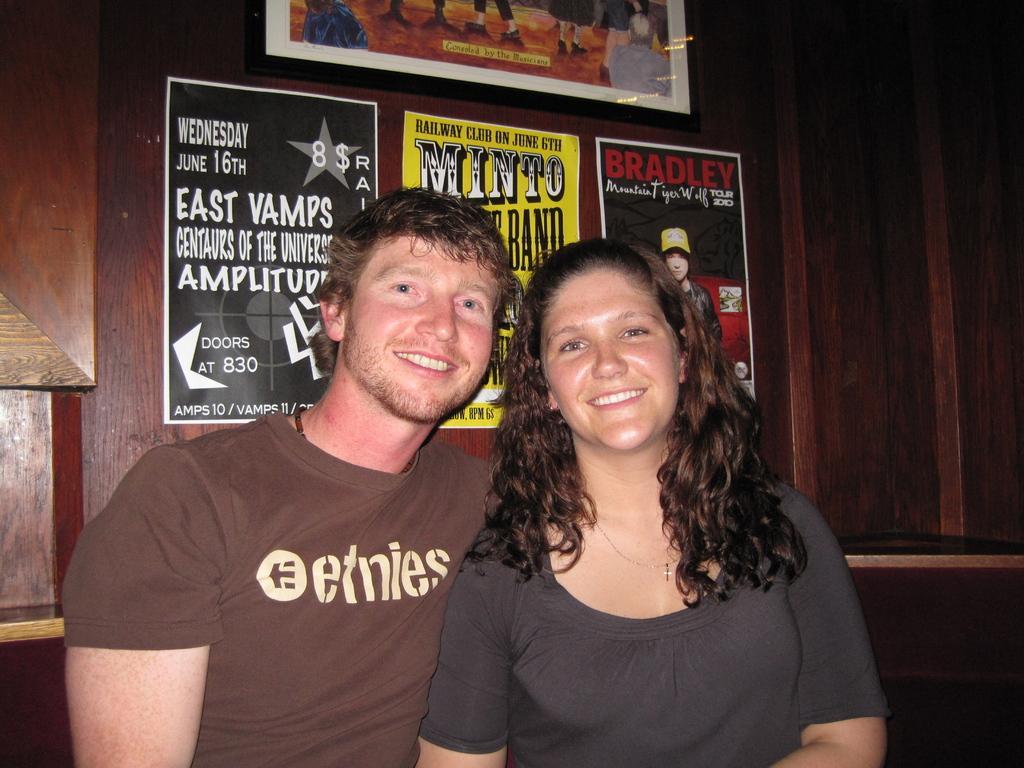How would you summarize this image in a sentence or two? In this image, we can see a man and a lady smiling and in the background, there are posters and a frame on the wall. 